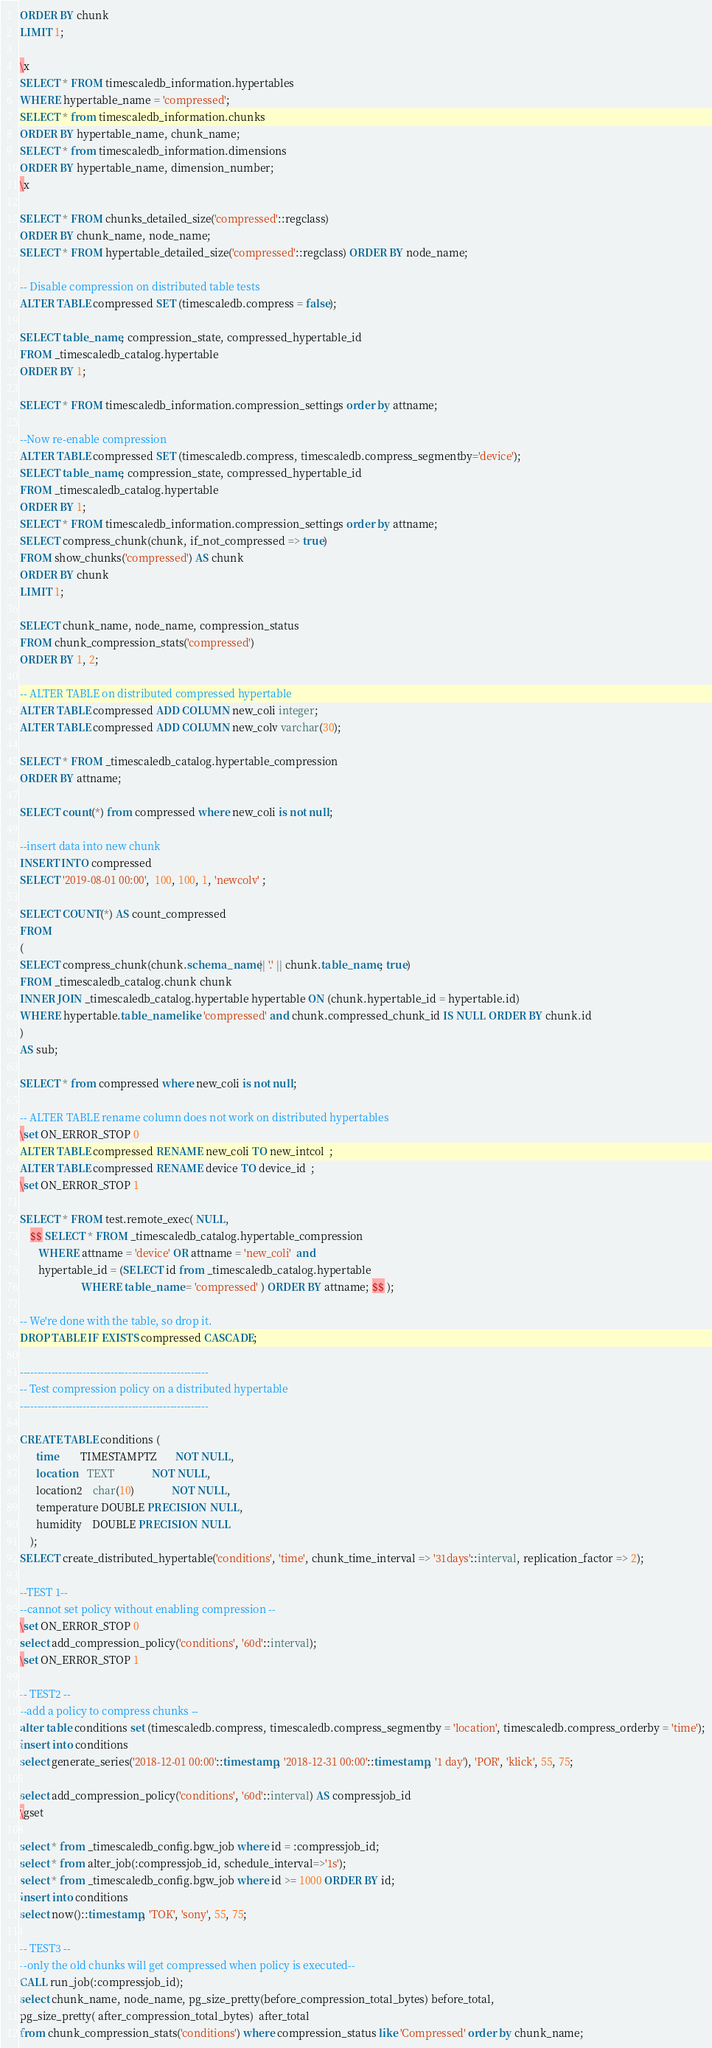Convert code to text. <code><loc_0><loc_0><loc_500><loc_500><_SQL_>ORDER BY chunk
LIMIT 1;

\x
SELECT * FROM timescaledb_information.hypertables
WHERE hypertable_name = 'compressed';
SELECT * from timescaledb_information.chunks 
ORDER BY hypertable_name, chunk_name;
SELECT * from timescaledb_information.dimensions 
ORDER BY hypertable_name, dimension_number;
\x

SELECT * FROM chunks_detailed_size('compressed'::regclass) 
ORDER BY chunk_name, node_name;
SELECT * FROM hypertable_detailed_size('compressed'::regclass) ORDER BY node_name;

-- Disable compression on distributed table tests
ALTER TABLE compressed SET (timescaledb.compress = false);

SELECT table_name, compression_state, compressed_hypertable_id
FROM _timescaledb_catalog.hypertable
ORDER BY 1;

SELECT * FROM timescaledb_information.compression_settings order by attname;

--Now re-enable compression
ALTER TABLE compressed SET (timescaledb.compress, timescaledb.compress_segmentby='device');
SELECT table_name, compression_state, compressed_hypertable_id
FROM _timescaledb_catalog.hypertable
ORDER BY 1;
SELECT * FROM timescaledb_information.compression_settings order by attname;
SELECT compress_chunk(chunk, if_not_compressed => true)
FROM show_chunks('compressed') AS chunk
ORDER BY chunk
LIMIT 1;

SELECT chunk_name, node_name, compression_status
FROM chunk_compression_stats('compressed')
ORDER BY 1, 2;

-- ALTER TABLE on distributed compressed hypertable
ALTER TABLE compressed ADD COLUMN new_coli integer;
ALTER TABLE compressed ADD COLUMN new_colv varchar(30);

SELECT * FROM _timescaledb_catalog.hypertable_compression
ORDER BY attname;

SELECT count(*) from compressed where new_coli is not null;

--insert data into new chunk  
INSERT INTO compressed 
SELECT '2019-08-01 00:00',  100, 100, 1, 'newcolv' ;

SELECT COUNT(*) AS count_compressed
FROM
(
SELECT compress_chunk(chunk.schema_name|| '.' || chunk.table_name, true)
FROM _timescaledb_catalog.chunk chunk
INNER JOIN _timescaledb_catalog.hypertable hypertable ON (chunk.hypertable_id = hypertable.id)
WHERE hypertable.table_name like 'compressed' and chunk.compressed_chunk_id IS NULL ORDER BY chunk.id
)
AS sub;

SELECT * from compressed where new_coli is not null;

-- ALTER TABLE rename column does not work on distributed hypertables
\set ON_ERROR_STOP 0
ALTER TABLE compressed RENAME new_coli TO new_intcol  ;
ALTER TABLE compressed RENAME device TO device_id  ;
\set ON_ERROR_STOP 1

SELECT * FROM test.remote_exec( NULL, 
    $$ SELECT * FROM _timescaledb_catalog.hypertable_compression
       WHERE attname = 'device' OR attname = 'new_coli'  and 
       hypertable_id = (SELECT id from _timescaledb_catalog.hypertable
                       WHERE table_name = 'compressed' ) ORDER BY attname; $$ );

-- We're done with the table, so drop it.
DROP TABLE IF EXISTS compressed CASCADE;

------------------------------------------------------
-- Test compression policy on a distributed hypertable
------------------------------------------------------

CREATE TABLE conditions (
      time        TIMESTAMPTZ       NOT NULL,
      location    TEXT              NOT NULL,
      location2    char(10)              NOT NULL,
      temperature DOUBLE PRECISION  NULL,
      humidity    DOUBLE PRECISION  NULL
    );
SELECT create_distributed_hypertable('conditions', 'time', chunk_time_interval => '31days'::interval, replication_factor => 2);

--TEST 1--
--cannot set policy without enabling compression --
\set ON_ERROR_STOP 0
select add_compression_policy('conditions', '60d'::interval);
\set ON_ERROR_STOP 1

-- TEST2 --
--add a policy to compress chunks --
alter table conditions set (timescaledb.compress, timescaledb.compress_segmentby = 'location', timescaledb.compress_orderby = 'time');
insert into conditions
select generate_series('2018-12-01 00:00'::timestamp, '2018-12-31 00:00'::timestamp, '1 day'), 'POR', 'klick', 55, 75;

select add_compression_policy('conditions', '60d'::interval) AS compressjob_id
\gset

select * from _timescaledb_config.bgw_job where id = :compressjob_id;
select * from alter_job(:compressjob_id, schedule_interval=>'1s');
select * from _timescaledb_config.bgw_job where id >= 1000 ORDER BY id;
insert into conditions
select now()::timestamp, 'TOK', 'sony', 55, 75;

-- TEST3 --
--only the old chunks will get compressed when policy is executed--
CALL run_job(:compressjob_id);
select chunk_name, node_name, pg_size_pretty(before_compression_total_bytes) before_total,
pg_size_pretty( after_compression_total_bytes)  after_total
from chunk_compression_stats('conditions') where compression_status like 'Compressed' order by chunk_name;</code> 